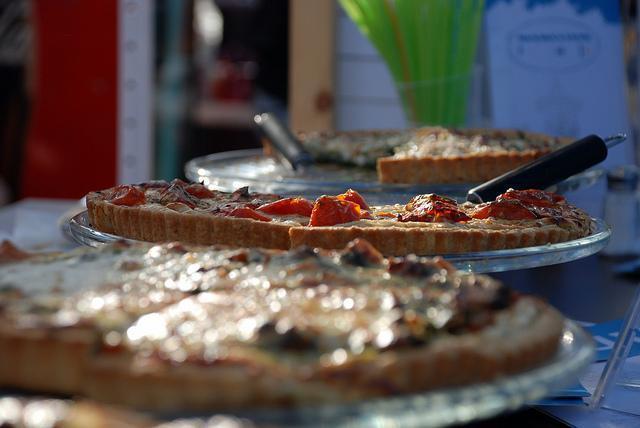How many pizzas are in the photo?
Give a very brief answer. 3. How many people are sitting or standing on top of the steps in the back?
Give a very brief answer. 0. 